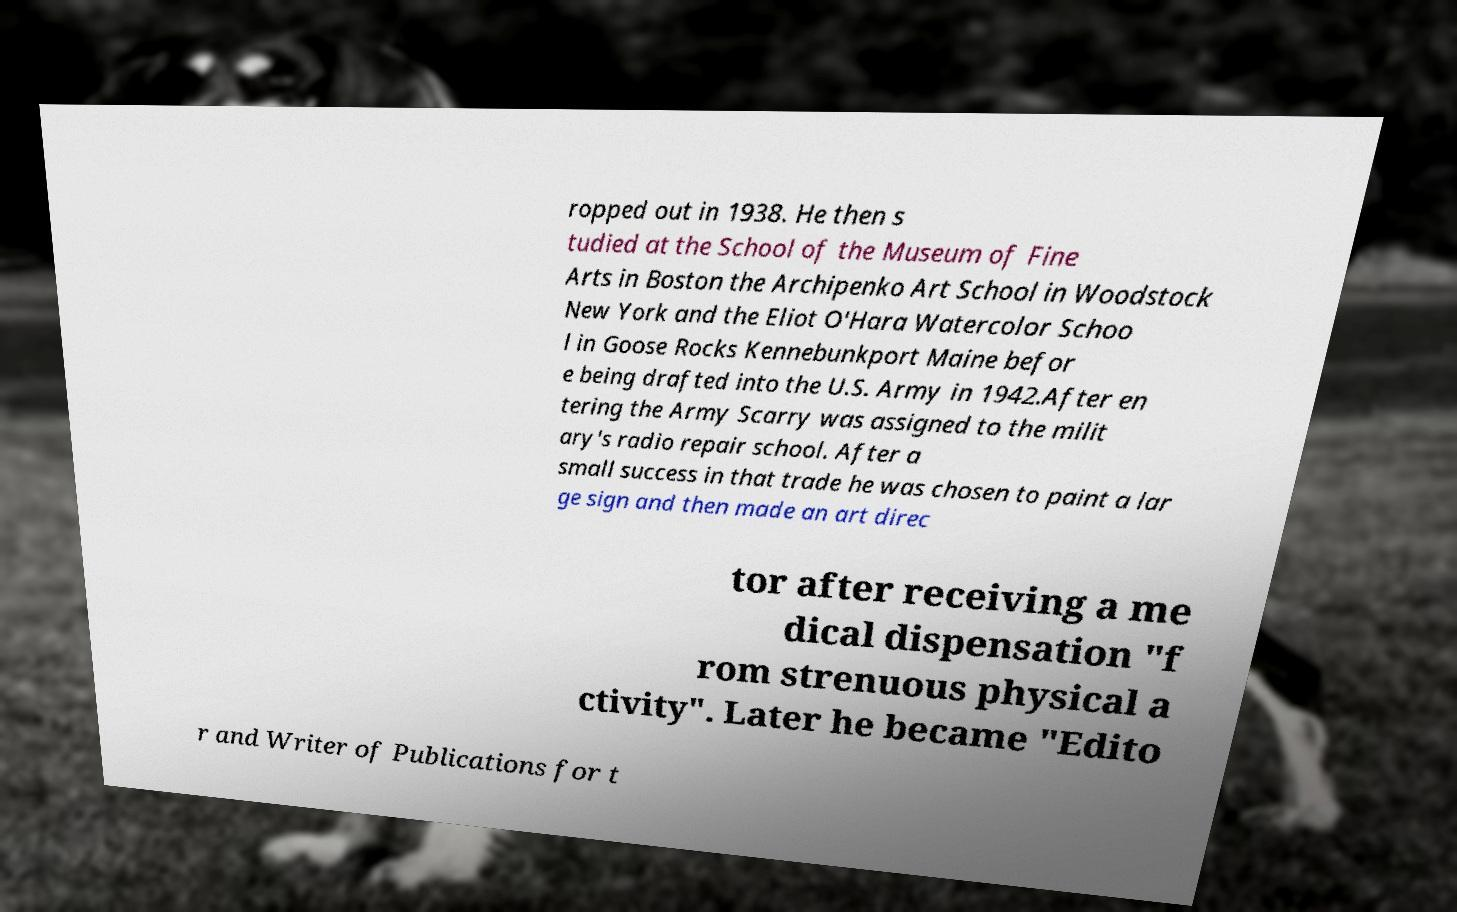Could you assist in decoding the text presented in this image and type it out clearly? ropped out in 1938. He then s tudied at the School of the Museum of Fine Arts in Boston the Archipenko Art School in Woodstock New York and the Eliot O'Hara Watercolor Schoo l in Goose Rocks Kennebunkport Maine befor e being drafted into the U.S. Army in 1942.After en tering the Army Scarry was assigned to the milit ary's radio repair school. After a small success in that trade he was chosen to paint a lar ge sign and then made an art direc tor after receiving a me dical dispensation "f rom strenuous physical a ctivity". Later he became "Edito r and Writer of Publications for t 